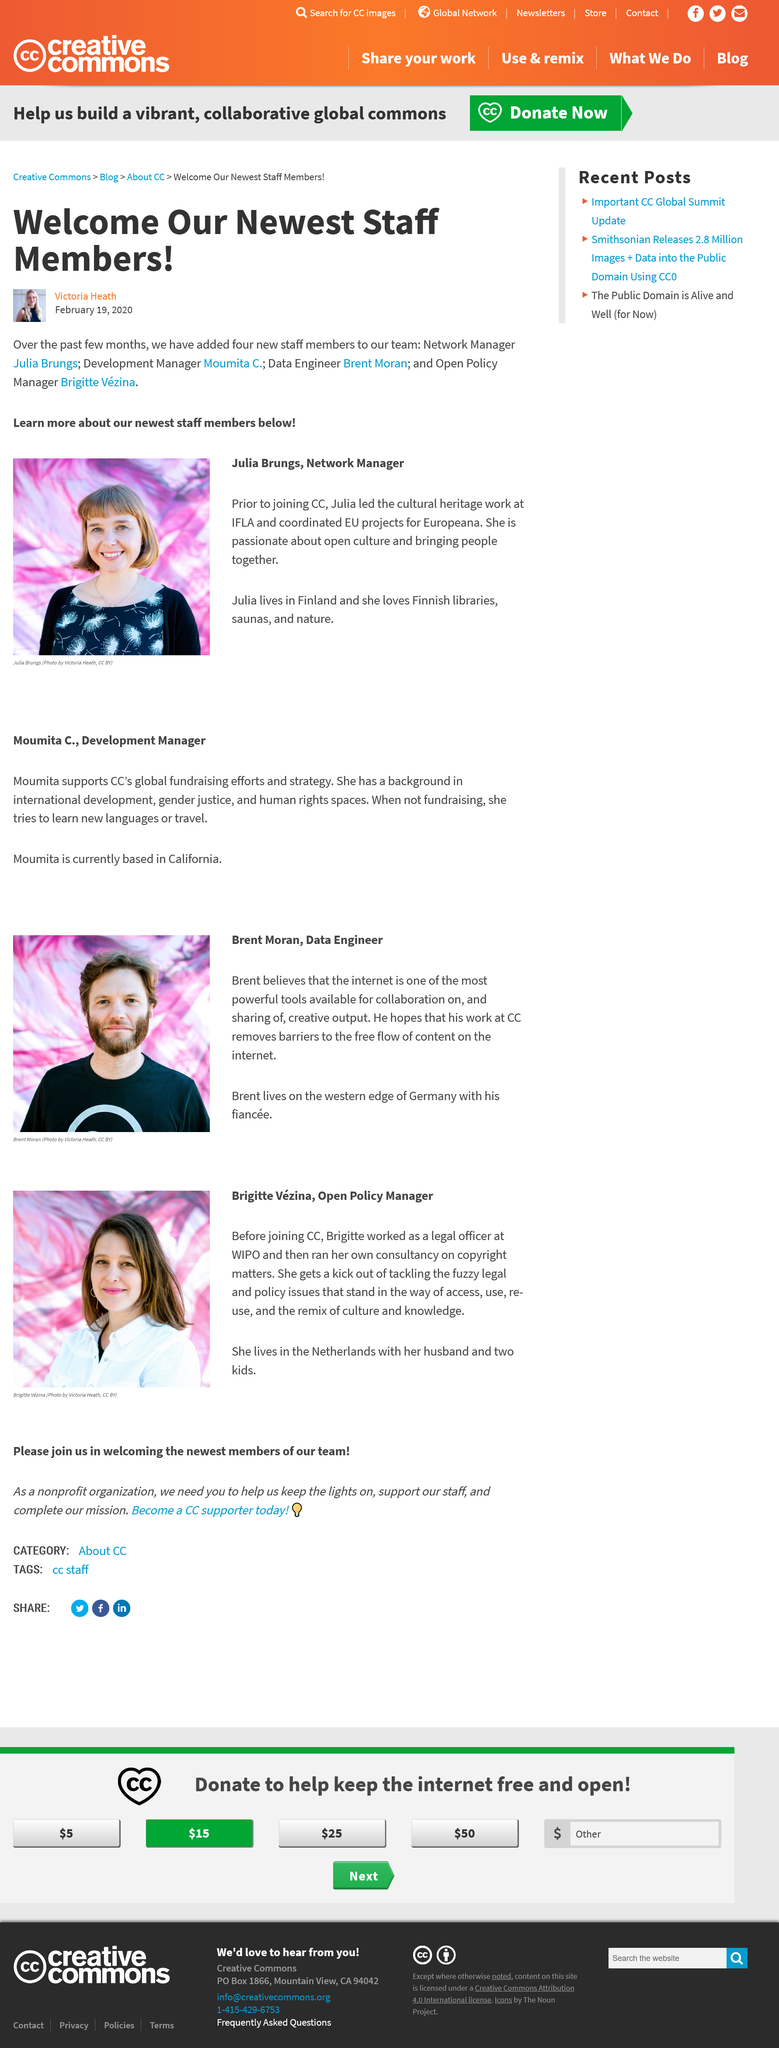Mention a couple of crucial points in this snapshot. Julia lives in Finland. Brigitte lives with her husband and two children. Brigitte holds the position of Open Policy Manager at CC. New members of the team include a network manager, a development manager, a data engineer, and an open policy manager, each bringing unique skills and expertise to the team. Brent believes that the internet is one of the most powerful tools for collaboration. 